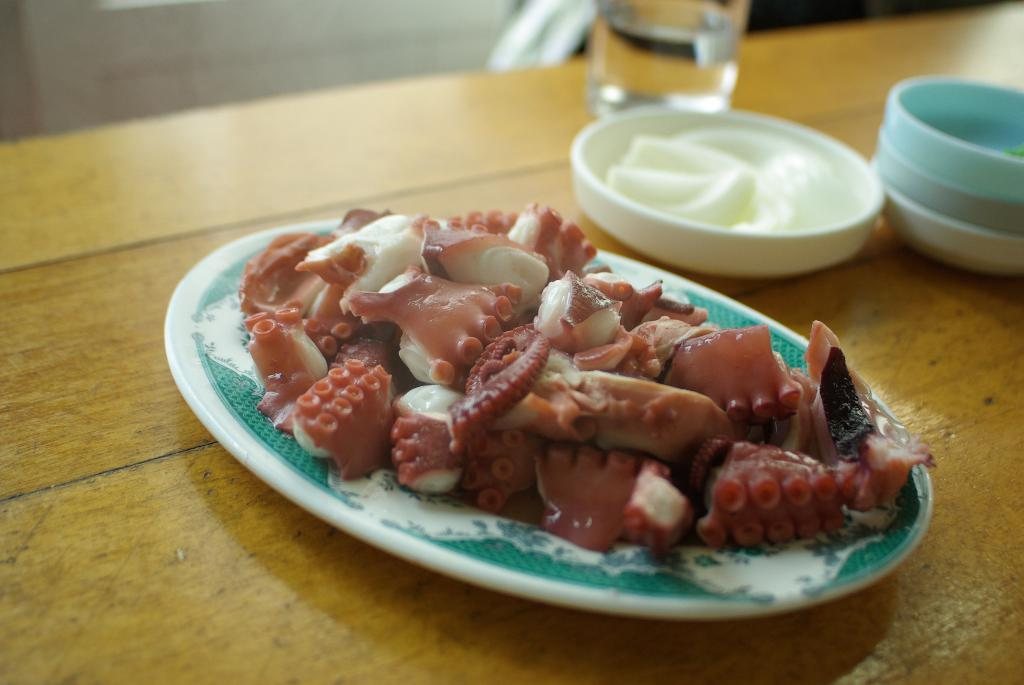What is on the plate in the image? There are objects on a plate in the image. What is the purpose of the lid in the image? The purpose of the lid is not clear from the image, but it could be used to cover or protect the objects on the plate. What is the shape of the box in the image? The shape of the box in the image is not clear from the provided facts. What is on the table in the image? There is a glass on a table in the image. What can be seen in the background of the image? There is a wall visible in the background of the image. How does the angle of the objects on the plate affect the range of the pollution in the image? There is no mention of angle, range, or pollution in the image, so it is not possible to answer this question. 